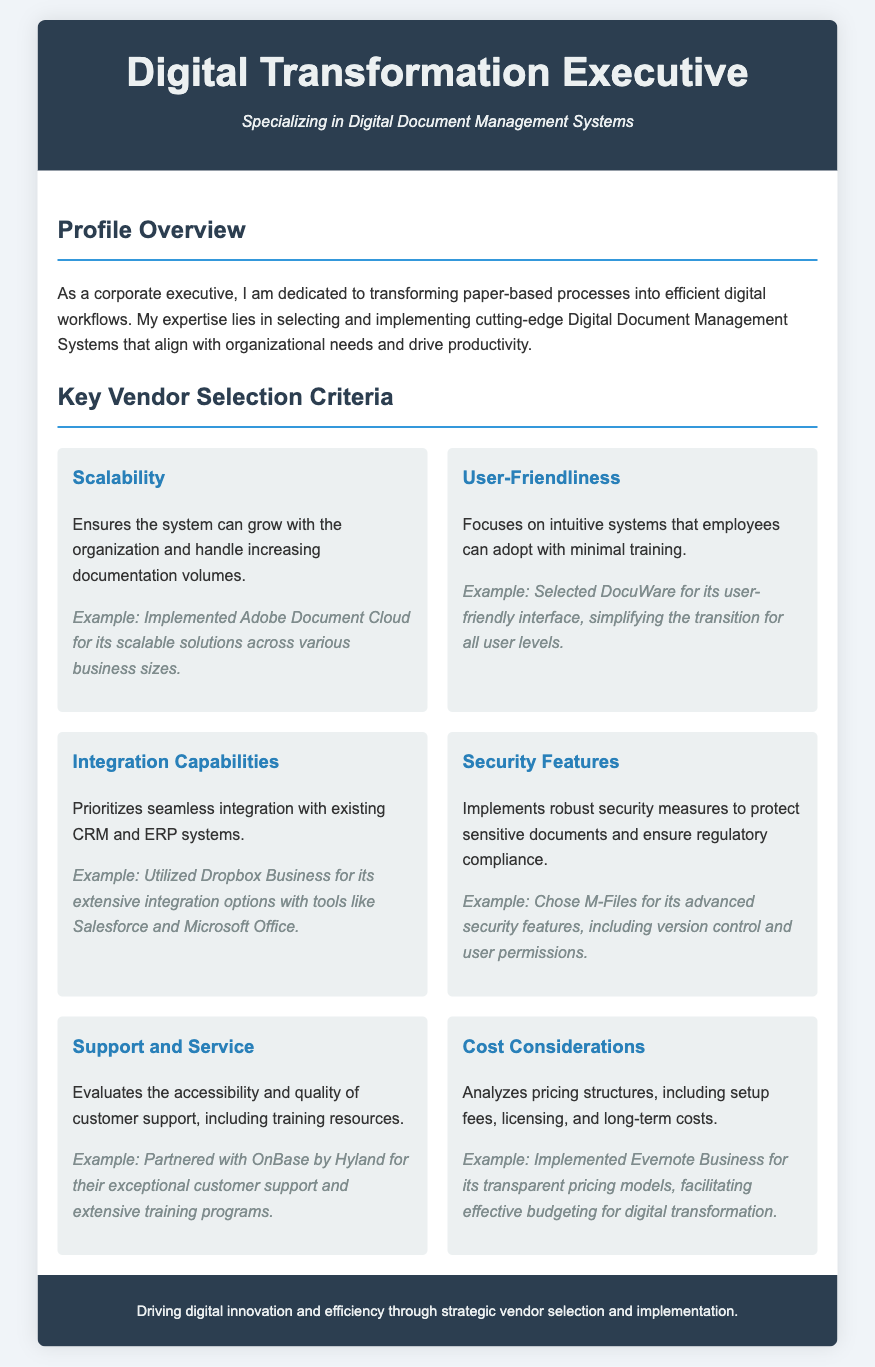What is the primary focus of the executive? The document states the executive's dedication to transforming paper-based processes into efficient digital workflows.
Answer: Digital workflows What system was implemented for its scalability? The document mentions Adobe Document Cloud as a system implemented for its scalable solutions.
Answer: Adobe Document Cloud Which vendor was selected for its user-friendly interface? The document highlights DocuWare as the selected vendor due to its user-friendly interface.
Answer: DocuWare What are the key security features mentioned? The document refers to advanced security features like version control and user permissions for M-Files.
Answer: Version control and user permissions What does the executive analyze under cost considerations? The document specifies the evaluation of pricing structures, setup fees, licensing, and long-term costs.
Answer: Pricing structures Which vendor was partnered with for exceptional customer support? The document indicates OnBase by Hyland was partnered for its customer support and training programs.
Answer: OnBase by Hyland How many key vendor selection criteria are listed? The document enumerates a total of six key vendor selection criteria.
Answer: Six What is the document type? The document is formatted as a Curriculum Vitae.
Answer: Curriculum Vitae What is the subtitle of the executive's CV? The document presents a subtitle indicating a specialization in Digital Document Management Systems.
Answer: Digital Document Management Systems 